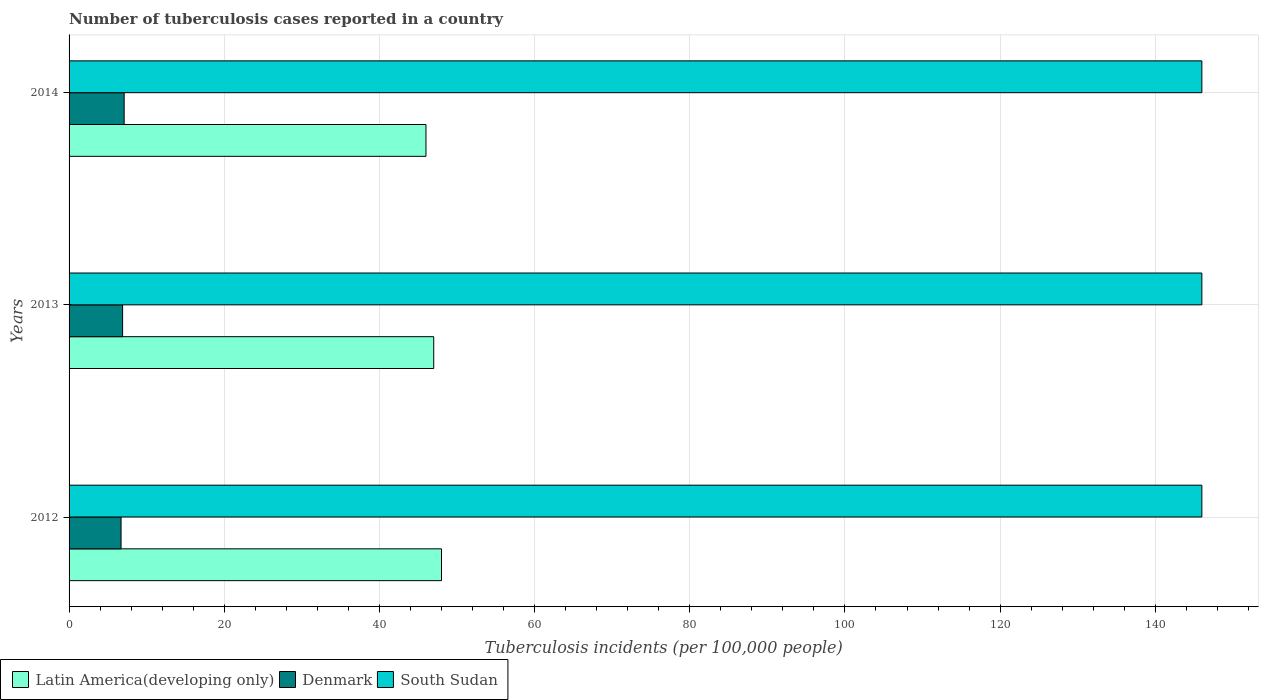How many different coloured bars are there?
Ensure brevity in your answer.  3. What is the label of the 2nd group of bars from the top?
Make the answer very short. 2013. In how many cases, is the number of bars for a given year not equal to the number of legend labels?
Give a very brief answer. 0. What is the number of tuberculosis cases reported in in South Sudan in 2013?
Your response must be concise. 146. Across all years, what is the maximum number of tuberculosis cases reported in in Denmark?
Provide a succinct answer. 7.1. In which year was the number of tuberculosis cases reported in in Denmark maximum?
Offer a very short reply. 2014. What is the total number of tuberculosis cases reported in in Latin America(developing only) in the graph?
Offer a very short reply. 141. What is the difference between the number of tuberculosis cases reported in in Denmark in 2012 and that in 2013?
Offer a terse response. -0.2. What is the difference between the number of tuberculosis cases reported in in Latin America(developing only) in 2014 and the number of tuberculosis cases reported in in South Sudan in 2013?
Provide a succinct answer. -100. What is the average number of tuberculosis cases reported in in Denmark per year?
Provide a succinct answer. 6.9. In the year 2012, what is the difference between the number of tuberculosis cases reported in in Denmark and number of tuberculosis cases reported in in Latin America(developing only)?
Give a very brief answer. -41.3. In how many years, is the number of tuberculosis cases reported in in Denmark greater than 64 ?
Provide a short and direct response. 0. Is the number of tuberculosis cases reported in in Latin America(developing only) in 2013 less than that in 2014?
Provide a short and direct response. No. What is the difference between the highest and the lowest number of tuberculosis cases reported in in Latin America(developing only)?
Your answer should be compact. 2. In how many years, is the number of tuberculosis cases reported in in South Sudan greater than the average number of tuberculosis cases reported in in South Sudan taken over all years?
Your response must be concise. 0. Is the sum of the number of tuberculosis cases reported in in South Sudan in 2012 and 2014 greater than the maximum number of tuberculosis cases reported in in Latin America(developing only) across all years?
Your answer should be compact. Yes. What does the 3rd bar from the top in 2012 represents?
Ensure brevity in your answer.  Latin America(developing only). What does the 3rd bar from the bottom in 2013 represents?
Your answer should be compact. South Sudan. Is it the case that in every year, the sum of the number of tuberculosis cases reported in in Denmark and number of tuberculosis cases reported in in Latin America(developing only) is greater than the number of tuberculosis cases reported in in South Sudan?
Your answer should be compact. No. Are all the bars in the graph horizontal?
Give a very brief answer. Yes. How many years are there in the graph?
Keep it short and to the point. 3. What is the difference between two consecutive major ticks on the X-axis?
Your response must be concise. 20. What is the title of the graph?
Your response must be concise. Number of tuberculosis cases reported in a country. What is the label or title of the X-axis?
Offer a very short reply. Tuberculosis incidents (per 100,0 people). What is the Tuberculosis incidents (per 100,000 people) in Latin America(developing only) in 2012?
Your response must be concise. 48. What is the Tuberculosis incidents (per 100,000 people) in Denmark in 2012?
Offer a terse response. 6.7. What is the Tuberculosis incidents (per 100,000 people) in South Sudan in 2012?
Offer a terse response. 146. What is the Tuberculosis incidents (per 100,000 people) of Denmark in 2013?
Offer a very short reply. 6.9. What is the Tuberculosis incidents (per 100,000 people) of South Sudan in 2013?
Give a very brief answer. 146. What is the Tuberculosis incidents (per 100,000 people) in Latin America(developing only) in 2014?
Provide a succinct answer. 46. What is the Tuberculosis incidents (per 100,000 people) of South Sudan in 2014?
Your response must be concise. 146. Across all years, what is the maximum Tuberculosis incidents (per 100,000 people) in Latin America(developing only)?
Keep it short and to the point. 48. Across all years, what is the maximum Tuberculosis incidents (per 100,000 people) in Denmark?
Your answer should be compact. 7.1. Across all years, what is the maximum Tuberculosis incidents (per 100,000 people) of South Sudan?
Offer a terse response. 146. Across all years, what is the minimum Tuberculosis incidents (per 100,000 people) of Latin America(developing only)?
Make the answer very short. 46. Across all years, what is the minimum Tuberculosis incidents (per 100,000 people) in Denmark?
Keep it short and to the point. 6.7. Across all years, what is the minimum Tuberculosis incidents (per 100,000 people) in South Sudan?
Your answer should be very brief. 146. What is the total Tuberculosis incidents (per 100,000 people) in Latin America(developing only) in the graph?
Provide a succinct answer. 141. What is the total Tuberculosis incidents (per 100,000 people) of Denmark in the graph?
Keep it short and to the point. 20.7. What is the total Tuberculosis incidents (per 100,000 people) in South Sudan in the graph?
Your answer should be compact. 438. What is the difference between the Tuberculosis incidents (per 100,000 people) in Latin America(developing only) in 2012 and that in 2013?
Your response must be concise. 1. What is the difference between the Tuberculosis incidents (per 100,000 people) of Denmark in 2012 and that in 2013?
Make the answer very short. -0.2. What is the difference between the Tuberculosis incidents (per 100,000 people) of Latin America(developing only) in 2012 and that in 2014?
Provide a short and direct response. 2. What is the difference between the Tuberculosis incidents (per 100,000 people) of South Sudan in 2012 and that in 2014?
Keep it short and to the point. 0. What is the difference between the Tuberculosis incidents (per 100,000 people) in Latin America(developing only) in 2013 and that in 2014?
Ensure brevity in your answer.  1. What is the difference between the Tuberculosis incidents (per 100,000 people) of Latin America(developing only) in 2012 and the Tuberculosis incidents (per 100,000 people) of Denmark in 2013?
Ensure brevity in your answer.  41.1. What is the difference between the Tuberculosis incidents (per 100,000 people) of Latin America(developing only) in 2012 and the Tuberculosis incidents (per 100,000 people) of South Sudan in 2013?
Give a very brief answer. -98. What is the difference between the Tuberculosis incidents (per 100,000 people) in Denmark in 2012 and the Tuberculosis incidents (per 100,000 people) in South Sudan in 2013?
Keep it short and to the point. -139.3. What is the difference between the Tuberculosis incidents (per 100,000 people) of Latin America(developing only) in 2012 and the Tuberculosis incidents (per 100,000 people) of Denmark in 2014?
Provide a succinct answer. 40.9. What is the difference between the Tuberculosis incidents (per 100,000 people) in Latin America(developing only) in 2012 and the Tuberculosis incidents (per 100,000 people) in South Sudan in 2014?
Make the answer very short. -98. What is the difference between the Tuberculosis incidents (per 100,000 people) in Denmark in 2012 and the Tuberculosis incidents (per 100,000 people) in South Sudan in 2014?
Your response must be concise. -139.3. What is the difference between the Tuberculosis incidents (per 100,000 people) of Latin America(developing only) in 2013 and the Tuberculosis incidents (per 100,000 people) of Denmark in 2014?
Offer a terse response. 39.9. What is the difference between the Tuberculosis incidents (per 100,000 people) of Latin America(developing only) in 2013 and the Tuberculosis incidents (per 100,000 people) of South Sudan in 2014?
Provide a short and direct response. -99. What is the difference between the Tuberculosis incidents (per 100,000 people) of Denmark in 2013 and the Tuberculosis incidents (per 100,000 people) of South Sudan in 2014?
Your answer should be compact. -139.1. What is the average Tuberculosis incidents (per 100,000 people) in Latin America(developing only) per year?
Your answer should be compact. 47. What is the average Tuberculosis incidents (per 100,000 people) of South Sudan per year?
Give a very brief answer. 146. In the year 2012, what is the difference between the Tuberculosis incidents (per 100,000 people) in Latin America(developing only) and Tuberculosis incidents (per 100,000 people) in Denmark?
Offer a terse response. 41.3. In the year 2012, what is the difference between the Tuberculosis incidents (per 100,000 people) of Latin America(developing only) and Tuberculosis incidents (per 100,000 people) of South Sudan?
Keep it short and to the point. -98. In the year 2012, what is the difference between the Tuberculosis incidents (per 100,000 people) in Denmark and Tuberculosis incidents (per 100,000 people) in South Sudan?
Give a very brief answer. -139.3. In the year 2013, what is the difference between the Tuberculosis incidents (per 100,000 people) in Latin America(developing only) and Tuberculosis incidents (per 100,000 people) in Denmark?
Keep it short and to the point. 40.1. In the year 2013, what is the difference between the Tuberculosis incidents (per 100,000 people) in Latin America(developing only) and Tuberculosis incidents (per 100,000 people) in South Sudan?
Give a very brief answer. -99. In the year 2013, what is the difference between the Tuberculosis incidents (per 100,000 people) in Denmark and Tuberculosis incidents (per 100,000 people) in South Sudan?
Your answer should be very brief. -139.1. In the year 2014, what is the difference between the Tuberculosis incidents (per 100,000 people) of Latin America(developing only) and Tuberculosis incidents (per 100,000 people) of Denmark?
Keep it short and to the point. 38.9. In the year 2014, what is the difference between the Tuberculosis incidents (per 100,000 people) in Latin America(developing only) and Tuberculosis incidents (per 100,000 people) in South Sudan?
Provide a succinct answer. -100. In the year 2014, what is the difference between the Tuberculosis incidents (per 100,000 people) of Denmark and Tuberculosis incidents (per 100,000 people) of South Sudan?
Give a very brief answer. -138.9. What is the ratio of the Tuberculosis incidents (per 100,000 people) in Latin America(developing only) in 2012 to that in 2013?
Provide a succinct answer. 1.02. What is the ratio of the Tuberculosis incidents (per 100,000 people) in South Sudan in 2012 to that in 2013?
Keep it short and to the point. 1. What is the ratio of the Tuberculosis incidents (per 100,000 people) of Latin America(developing only) in 2012 to that in 2014?
Offer a terse response. 1.04. What is the ratio of the Tuberculosis incidents (per 100,000 people) of Denmark in 2012 to that in 2014?
Ensure brevity in your answer.  0.94. What is the ratio of the Tuberculosis incidents (per 100,000 people) of South Sudan in 2012 to that in 2014?
Your response must be concise. 1. What is the ratio of the Tuberculosis incidents (per 100,000 people) of Latin America(developing only) in 2013 to that in 2014?
Ensure brevity in your answer.  1.02. What is the ratio of the Tuberculosis incidents (per 100,000 people) of Denmark in 2013 to that in 2014?
Your response must be concise. 0.97. What is the difference between the highest and the second highest Tuberculosis incidents (per 100,000 people) in Denmark?
Your answer should be compact. 0.2. What is the difference between the highest and the second highest Tuberculosis incidents (per 100,000 people) of South Sudan?
Give a very brief answer. 0. What is the difference between the highest and the lowest Tuberculosis incidents (per 100,000 people) in Denmark?
Make the answer very short. 0.4. 